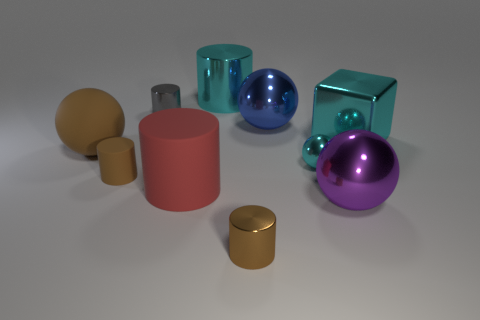Subtract all metal spheres. How many spheres are left? 1 Subtract all purple spheres. How many spheres are left? 3 Subtract 2 brown cylinders. How many objects are left? 8 Subtract all balls. How many objects are left? 6 Subtract 4 spheres. How many spheres are left? 0 Subtract all green spheres. Subtract all gray blocks. How many spheres are left? 4 Subtract all purple balls. How many green cylinders are left? 0 Subtract all small brown rubber cylinders. Subtract all big things. How many objects are left? 3 Add 7 large blue shiny objects. How many large blue shiny objects are left? 8 Add 8 small matte things. How many small matte things exist? 9 